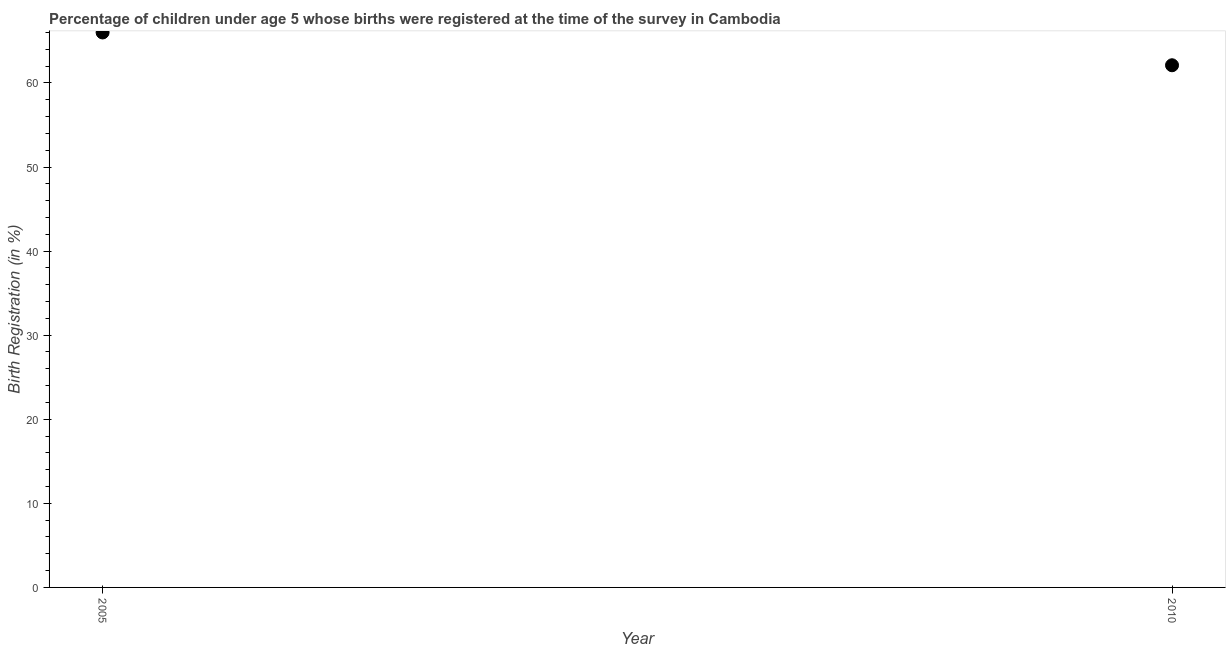Across all years, what is the minimum birth registration?
Keep it short and to the point. 62.1. In which year was the birth registration maximum?
Make the answer very short. 2005. In which year was the birth registration minimum?
Make the answer very short. 2010. What is the sum of the birth registration?
Provide a succinct answer. 128.1. What is the difference between the birth registration in 2005 and 2010?
Make the answer very short. 3.9. What is the average birth registration per year?
Make the answer very short. 64.05. What is the median birth registration?
Ensure brevity in your answer.  64.05. What is the ratio of the birth registration in 2005 to that in 2010?
Provide a succinct answer. 1.06. Does the birth registration monotonically increase over the years?
Provide a succinct answer. No. How many years are there in the graph?
Provide a succinct answer. 2. What is the difference between two consecutive major ticks on the Y-axis?
Your response must be concise. 10. Does the graph contain grids?
Your response must be concise. No. What is the title of the graph?
Your response must be concise. Percentage of children under age 5 whose births were registered at the time of the survey in Cambodia. What is the label or title of the Y-axis?
Make the answer very short. Birth Registration (in %). What is the Birth Registration (in %) in 2005?
Ensure brevity in your answer.  66. What is the Birth Registration (in %) in 2010?
Your answer should be very brief. 62.1. What is the ratio of the Birth Registration (in %) in 2005 to that in 2010?
Provide a succinct answer. 1.06. 